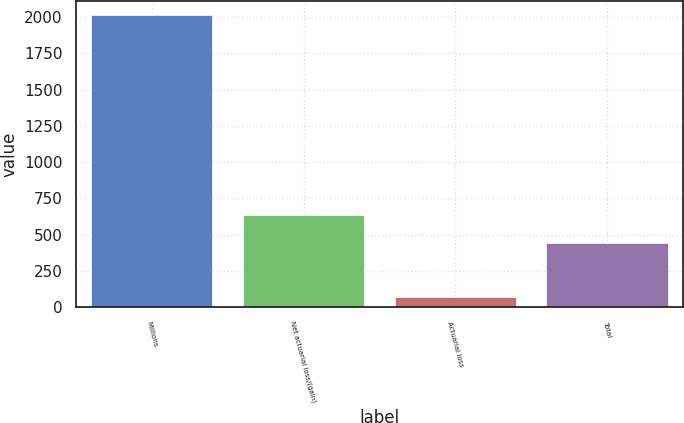<chart> <loc_0><loc_0><loc_500><loc_500><bar_chart><fcel>Millions<fcel>Net actuarial loss/(gain)<fcel>Actuarial loss<fcel>Total<nl><fcel>2011<fcel>636<fcel>71<fcel>442<nl></chart> 